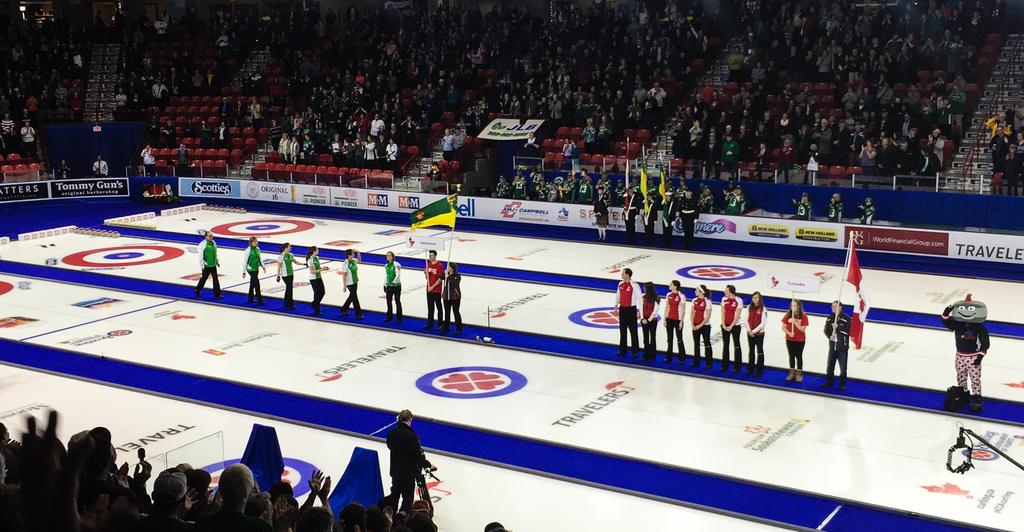What advertisement sign has a repeating logo next to it?
Your answer should be compact. Travelers. 